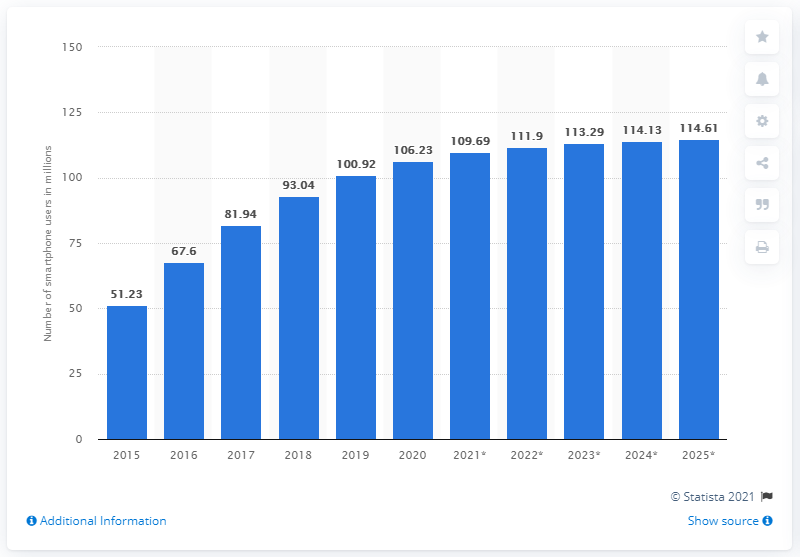Give some essential details in this illustration. According to estimates, there will be approximately 109.69 million smartphone users in Russia by the end of 2021. According to the prediction, by the year 2025, the number of smartphone users in Russia is expected to reach 114.61 million. 